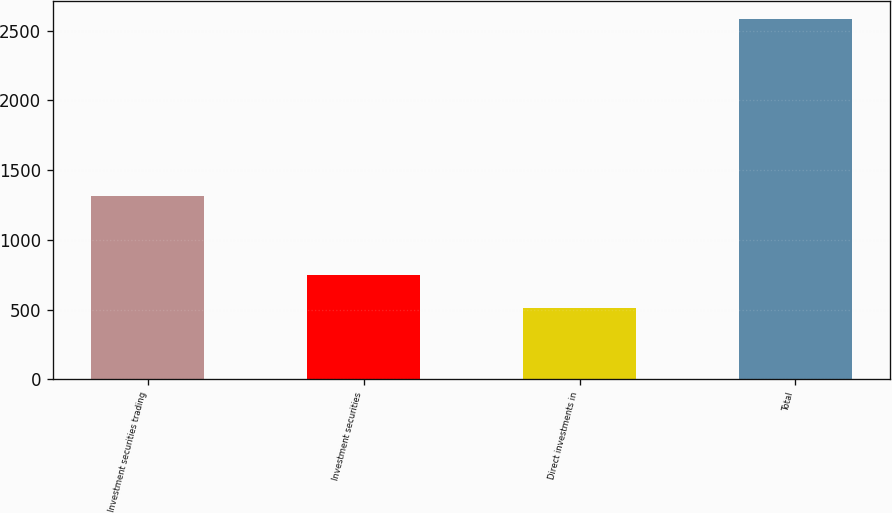Convert chart to OTSL. <chart><loc_0><loc_0><loc_500><loc_500><bar_chart><fcel>Investment securities trading<fcel>Investment securities<fcel>Direct investments in<fcel>Total<nl><fcel>1316.4<fcel>750.4<fcel>514.8<fcel>2581.6<nl></chart> 